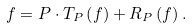Convert formula to latex. <formula><loc_0><loc_0><loc_500><loc_500>f = P \cdot T _ { P } \left ( f \right ) + R _ { P } \left ( f \right ) .</formula> 